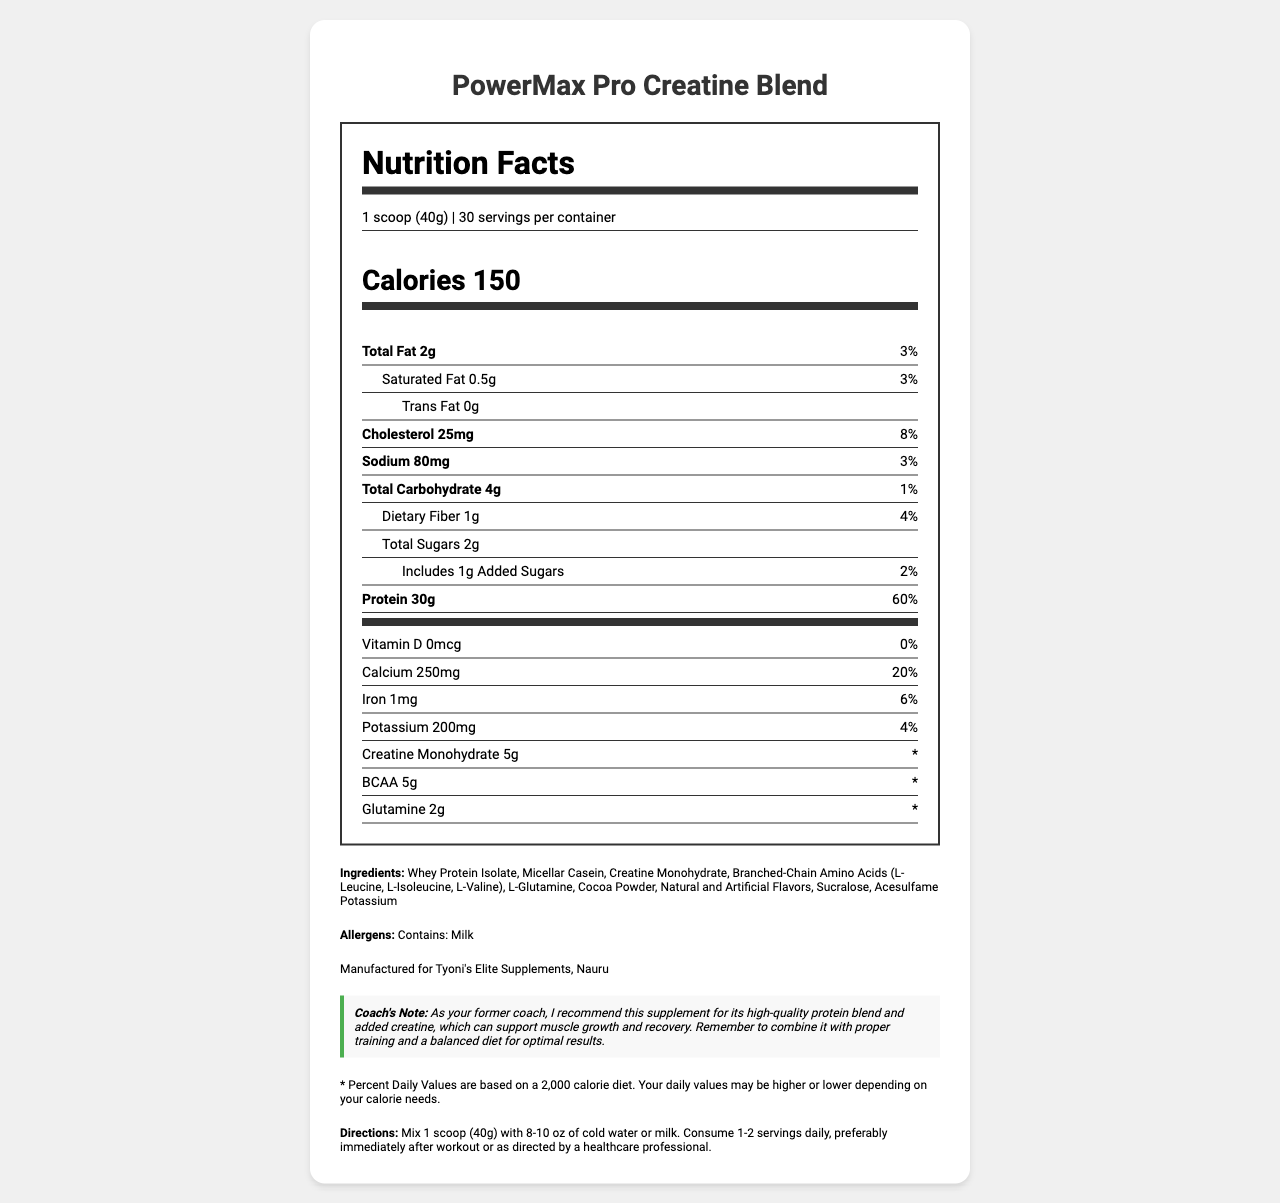What is the serving size for PowerMax Pro Creatine Blend? The serving size is listed as "1 scoop (40g)" in the serving information section.
Answer: 1 scoop (40g) How many calories are there per serving? The calorie content per serving is indicated as "Calories 150" in the calorie information section.
Answer: 150 What is the total amount of protein per serving and its daily value percentage? The amount of protein per serving is listed as "Protein 30g" with a daily value percentage of 60%.
Answer: 30g, 60% What are the ingredients in this supplement? The ingredients are listed in the ingredients section of the document.
Answer: Whey Protein Isolate, Micellar Casein, Creatine Monohydrate, Branched-Chain Amino Acids (L-Leucine, L-Isoleucine, L-Valine), L-Glutamine, Cocoa Powder, Natural and Artificial Flavors, Sucralose, Acesulfame Potassium What is the recommended serving frequency and timing for optimal results? The directions section of the document suggests consuming 1-2 servings daily, preferably immediately after workout or as directed by a healthcare professional.
Answer: 1-2 servings daily, preferably immediately after workout or as directed by a healthcare professional Which of the following is NOT a nutrient mentioned in this document? A. Vitamin D B. Vitamin C C. Calcium D. Iron Vitamin C is not mentioned in the document, whereas Vitamin D, Calcium, and Iron are listed in the vitamins section.
Answer: B What is the total fat content per serving? A. 2g B. 3g C. 4g D. 5g The total fat content per serving is listed as "Total Fat 2g" in the nutrient information section.
Answer: A Is there any added sugar in this supplement? The document mentions "Includes 1g Added Sugars" in the nutrient information section.
Answer: Yes Describe the main idea of the document. The document includes a nutrition facts label and additional sections such as ingredients, allergens, manufacturer information, coach's note, disclaimer, and directions for usage. It offers essential details about the supplement's nutritional content and how to use it effectively.
Answer: The document provides detailed nutrition information for PowerMax Pro Creatine Blend, a high-protein supplement with added creatine, including serving size, nutrient content, ingredients, allergens, and usage directions. What is Tyoni's favorite flavor for this supplement? The document does not provide any information about Tyoni's favorite flavor for the supplement.
Answer: Cannot be determined 